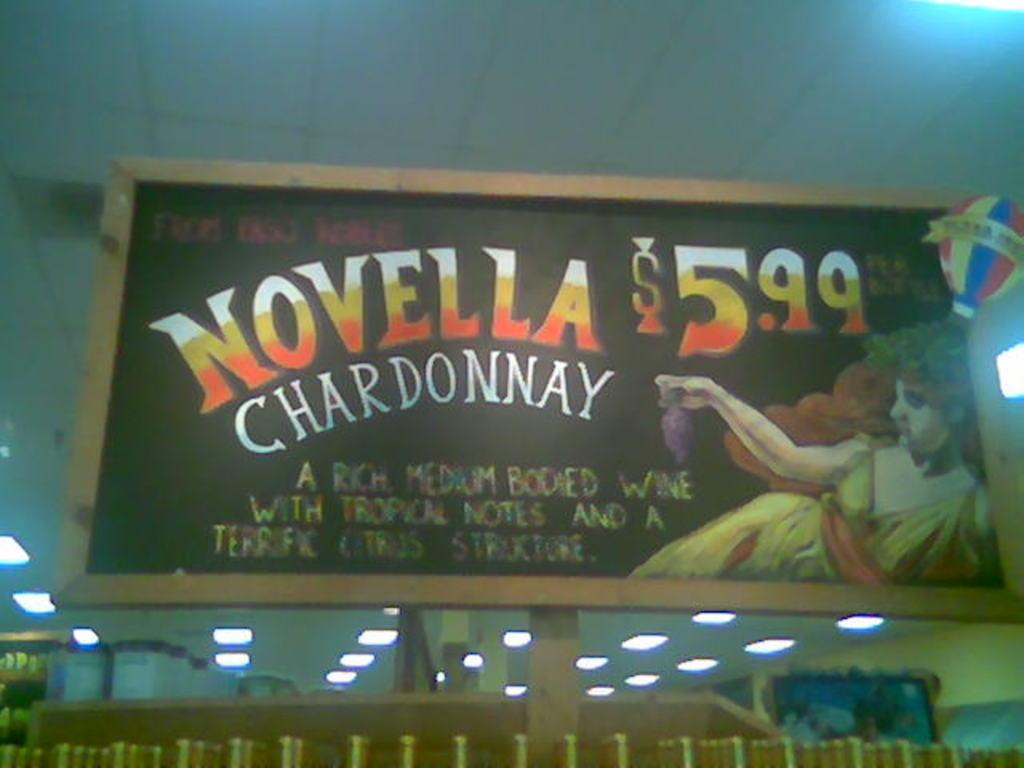Provide a one-sentence caption for the provided image. A store chalkboard advertising Novella Chardonnay for only 5.99. 